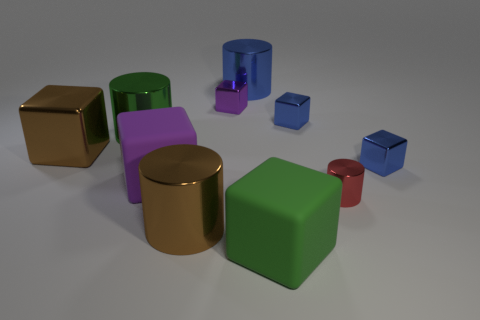Do the green rubber thing and the red object have the same shape?
Your answer should be compact. No. There is a green rubber thing; does it have the same shape as the large green thing to the left of the brown cylinder?
Your answer should be compact. No. Does the metal cylinder to the left of the large purple thing have the same color as the rubber thing in front of the red metal cylinder?
Offer a very short reply. Yes. Are there any metal cylinders that have the same color as the big metal block?
Provide a succinct answer. Yes. What number of big things have the same color as the big shiny cube?
Ensure brevity in your answer.  1. The large object that is the same material as the big purple block is what color?
Provide a succinct answer. Green. Is there a brown cube of the same size as the red cylinder?
Your response must be concise. No. How many objects are either small metallic objects that are on the left side of the big green matte cube or big green cubes that are in front of the brown metal cylinder?
Provide a succinct answer. 2. The blue shiny thing that is the same size as the green matte block is what shape?
Make the answer very short. Cylinder. Are there any brown shiny objects that have the same shape as the tiny purple object?
Your answer should be compact. Yes. 